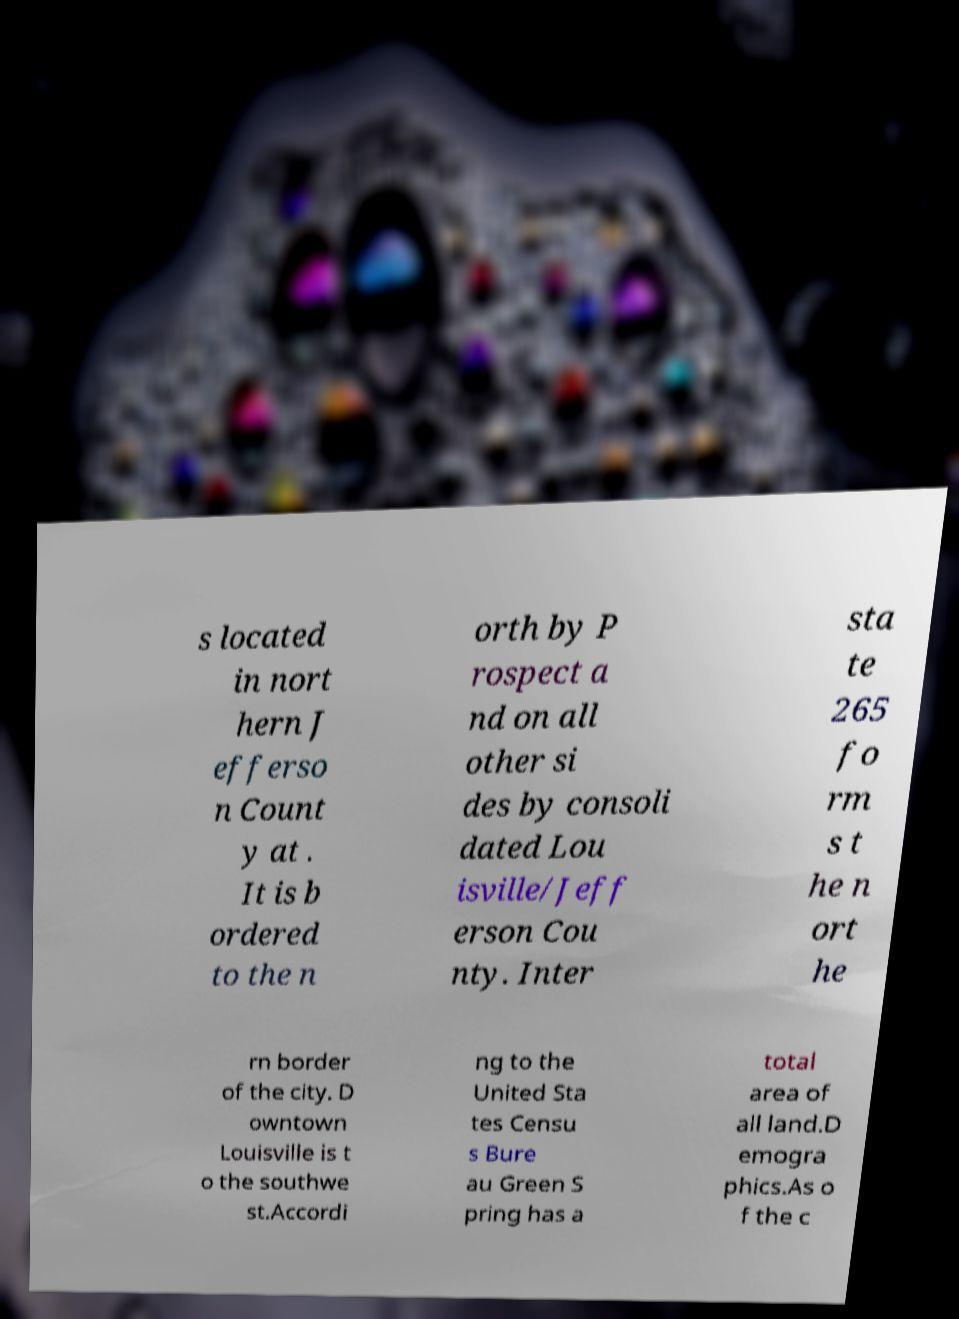Could you assist in decoding the text presented in this image and type it out clearly? s located in nort hern J efferso n Count y at . It is b ordered to the n orth by P rospect a nd on all other si des by consoli dated Lou isville/Jeff erson Cou nty. Inter sta te 265 fo rm s t he n ort he rn border of the city. D owntown Louisville is t o the southwe st.Accordi ng to the United Sta tes Censu s Bure au Green S pring has a total area of all land.D emogra phics.As o f the c 